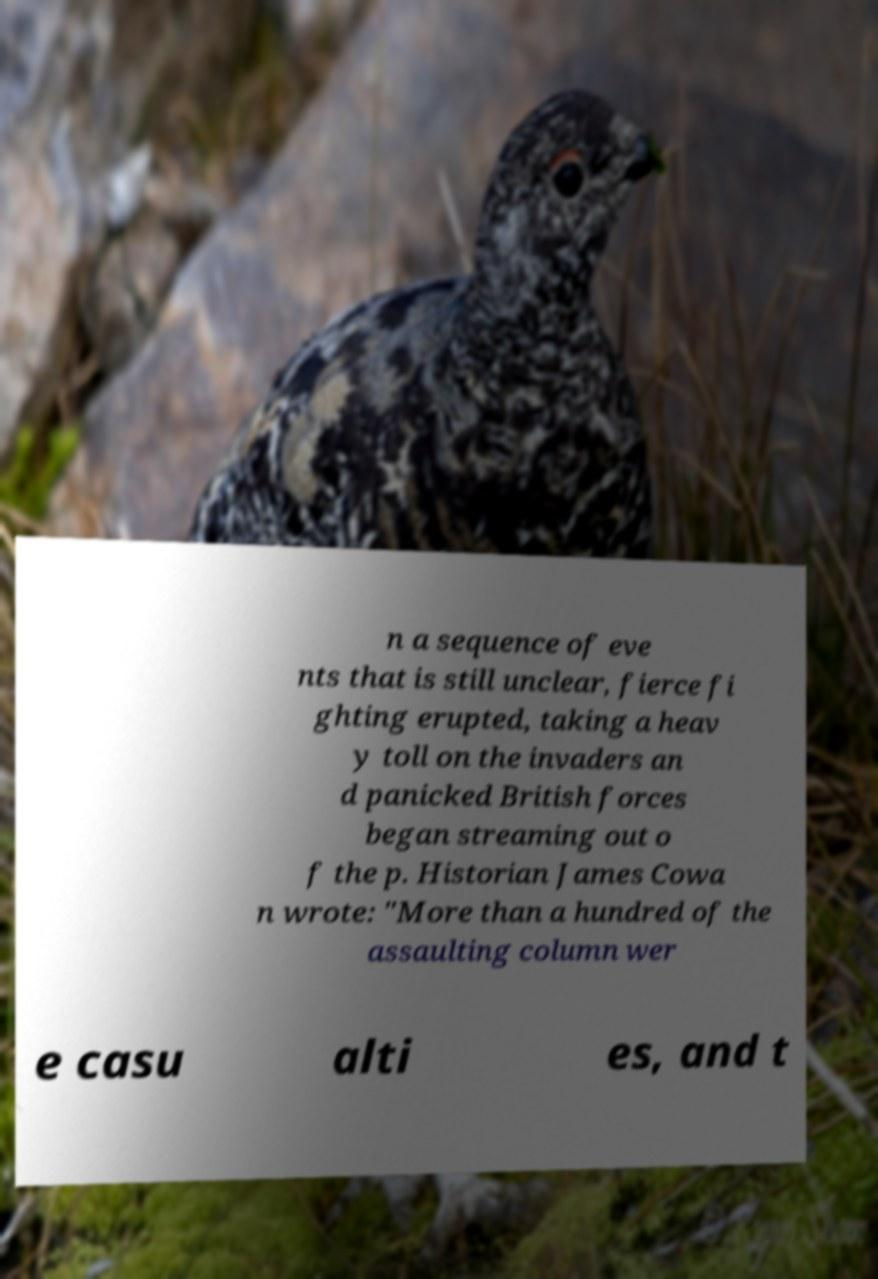Could you assist in decoding the text presented in this image and type it out clearly? n a sequence of eve nts that is still unclear, fierce fi ghting erupted, taking a heav y toll on the invaders an d panicked British forces began streaming out o f the p. Historian James Cowa n wrote: "More than a hundred of the assaulting column wer e casu alti es, and t 